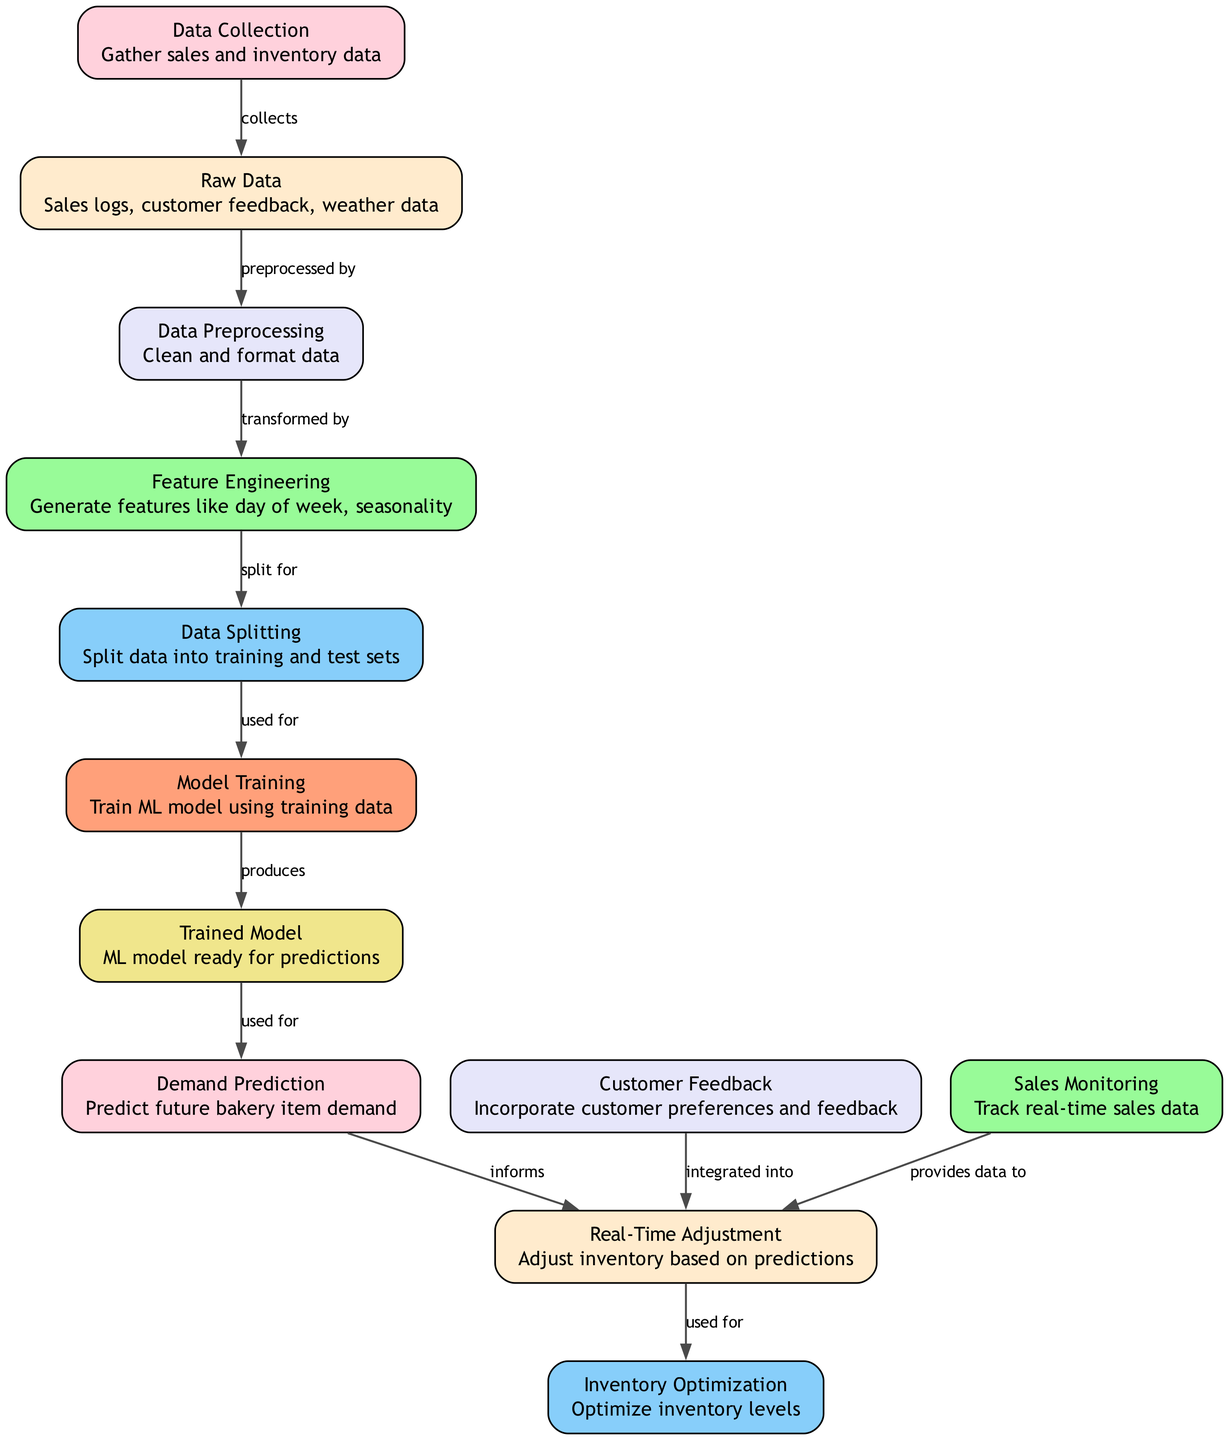What is the first node in the diagram? The first node, which represents the initial step in the process, is labeled "Data Collection". According to the diagram, this node is where the gathering of sales and inventory data begins.
Answer: Data Collection How many types of data are mentioned in the "Raw Data" node? The "Raw Data" node lists three specific types of data: sales logs, customer feedback, and weather data. Therefore, the total count of data types mentioned is three.
Answer: Three What does the "Model Training" node produce? The "Model Training" node leads to the next node labeled "Trained Model". This indicates that the output of the "Model Training" node is the generation of a trained machine learning model.
Answer: Trained Model Which node is integrated into the "Real-Time Adjustment" node? The "Customer Feedback" node provides information that is incorporated into the "Real-Time Adjustment" node. This indicates that customer preferences and feedback impact inventory adjustments.
Answer: Customer Feedback How many edges are present in the diagram? Counting the connections (edges) in the diagram reveals that there are a total of eleven edges linking the nodes together, representing how data or processes flow between them.
Answer: Eleven What role does "Sales Monitoring" play in the inventory process? The "Sales Monitoring" node provides data that informs the "Real-Time Adjustment" node, indicating its role in continuously tracking sales data to help make inventory adjustments based on real-time information.
Answer: Provides data to What is the purpose of the "Demand Prediction" node? The "Demand Prediction" node is primarily used for predicting future bakery item demand, which is critical for adjusting inventory to meet customer needs effectively.
Answer: Predict future bakery item demand Which nodes are connected to "Real-Time Adjustment"? The "Real-Time Adjustment" node is informed by three other nodes: "Demand Prediction", "Customer Feedback", and "Sales Monitoring". These connections show its reliance on multiple data inputs for inventory adjustments.
Answer: Demand Prediction, Customer Feedback, Sales Monitoring What is the final output of the diagram process? The final output of the diagram's process can be seen in the "Inventory Optimization" node, which indicates the end goal of the trained model and real-time adjustments leading to an optimized inventory level.
Answer: Inventory Optimization 